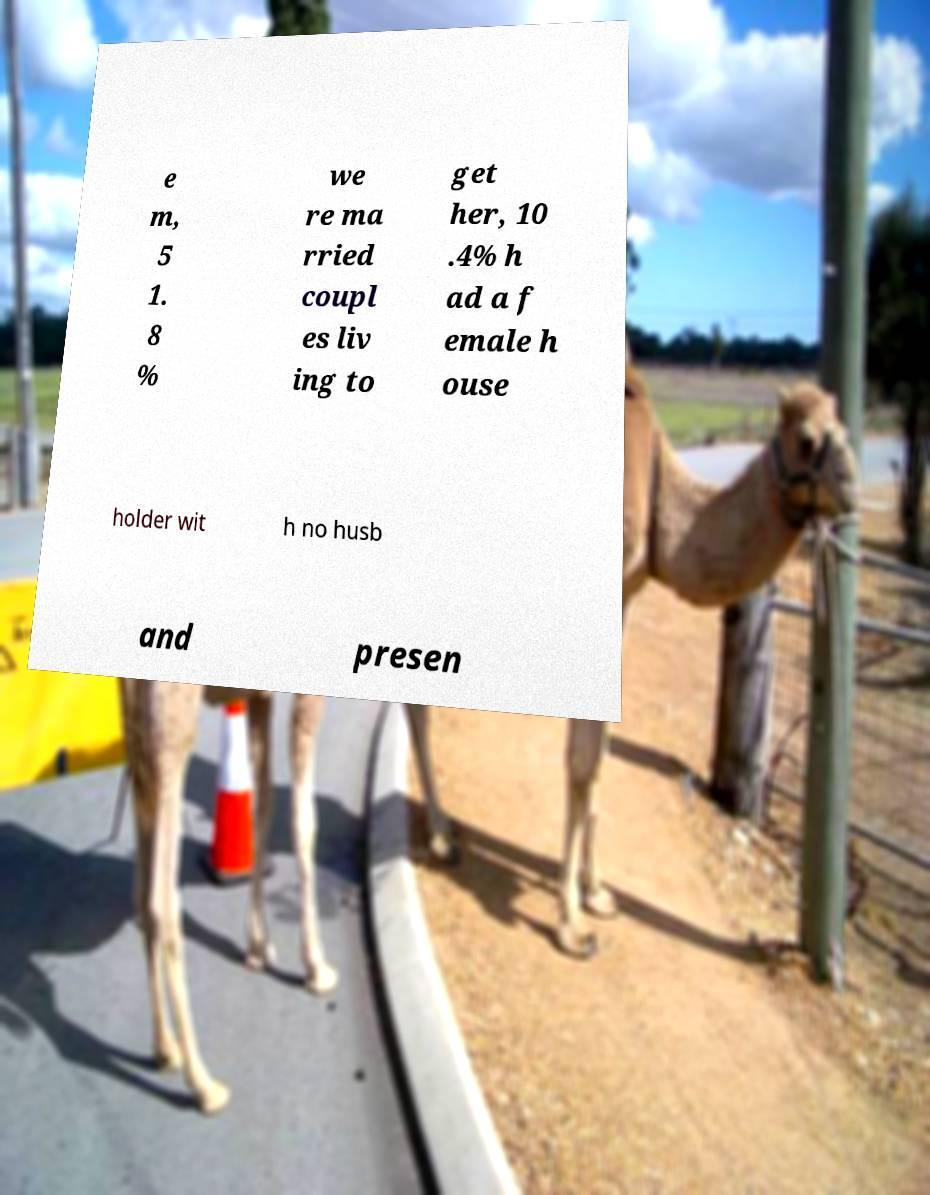Please read and relay the text visible in this image. What does it say? e m, 5 1. 8 % we re ma rried coupl es liv ing to get her, 10 .4% h ad a f emale h ouse holder wit h no husb and presen 